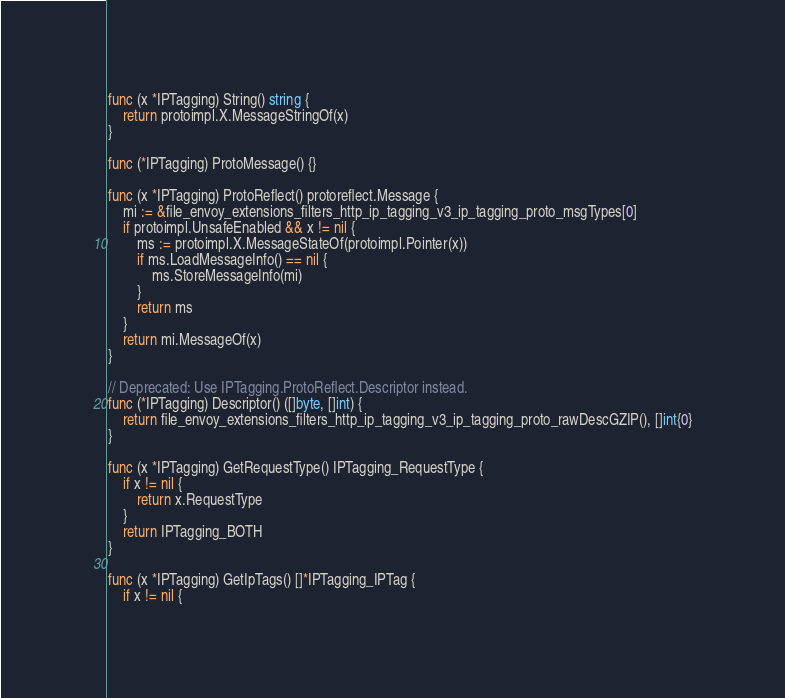Convert code to text. <code><loc_0><loc_0><loc_500><loc_500><_Go_>
func (x *IPTagging) String() string {
	return protoimpl.X.MessageStringOf(x)
}

func (*IPTagging) ProtoMessage() {}

func (x *IPTagging) ProtoReflect() protoreflect.Message {
	mi := &file_envoy_extensions_filters_http_ip_tagging_v3_ip_tagging_proto_msgTypes[0]
	if protoimpl.UnsafeEnabled && x != nil {
		ms := protoimpl.X.MessageStateOf(protoimpl.Pointer(x))
		if ms.LoadMessageInfo() == nil {
			ms.StoreMessageInfo(mi)
		}
		return ms
	}
	return mi.MessageOf(x)
}

// Deprecated: Use IPTagging.ProtoReflect.Descriptor instead.
func (*IPTagging) Descriptor() ([]byte, []int) {
	return file_envoy_extensions_filters_http_ip_tagging_v3_ip_tagging_proto_rawDescGZIP(), []int{0}
}

func (x *IPTagging) GetRequestType() IPTagging_RequestType {
	if x != nil {
		return x.RequestType
	}
	return IPTagging_BOTH
}

func (x *IPTagging) GetIpTags() []*IPTagging_IPTag {
	if x != nil {</code> 